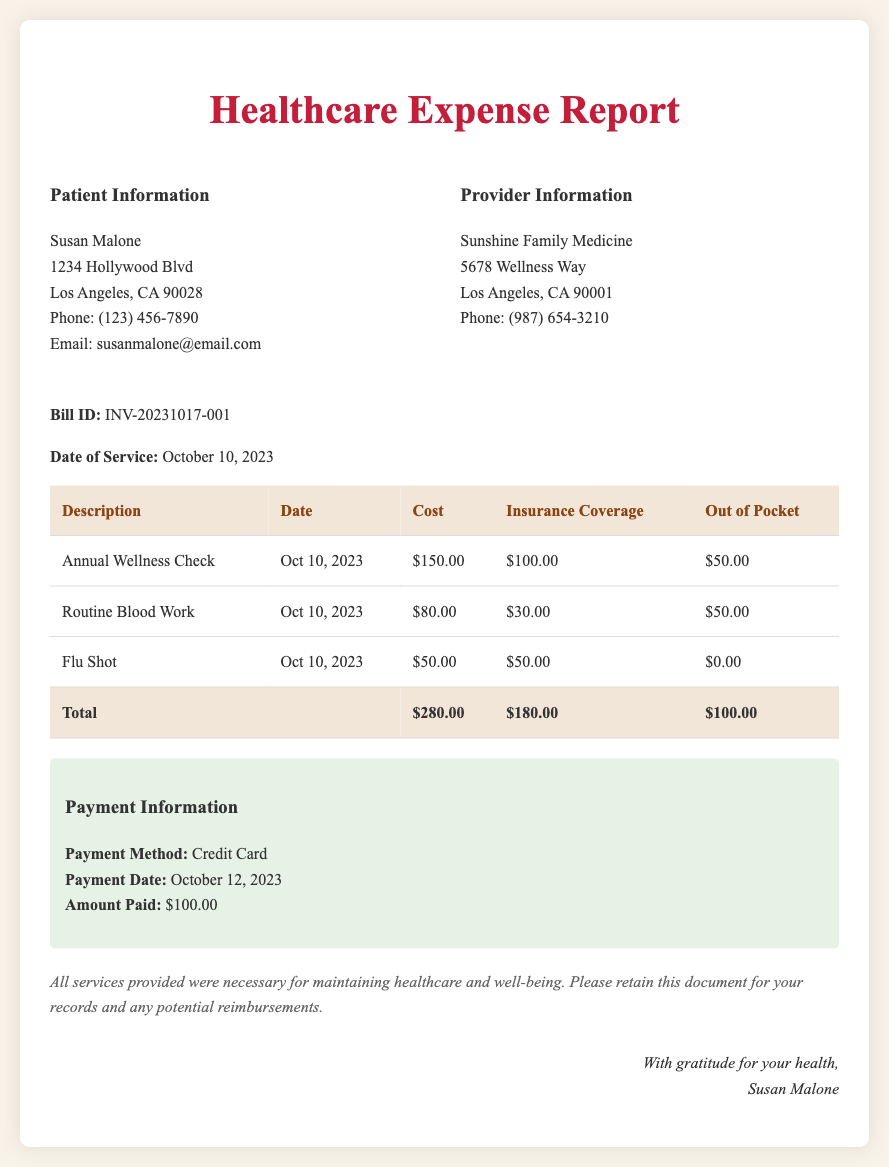what is the patient's name? The patient's name is listed in the document as Susan Malone.
Answer: Susan Malone what is the date of service? The date of service is mentioned as October 10, 2023.
Answer: October 10, 2023 how much was paid for the Annual Wellness Check? The cost for the Annual Wellness Check is specified as $150.00.
Answer: $150.00 how much was the total out-of-pocket cost? The total out-of-pocket cost is the sum of individual out-of-pocket costs listed, which is $50.00 + $50.00 + $0.00 = $100.00.
Answer: $100.00 when was the payment made? The payment date is included in the document as October 12, 2023.
Answer: October 12, 2023 what is the name of the healthcare provider? The healthcare provider is indicated as Sunshine Family Medicine.
Answer: Sunshine Family Medicine how much was the insurance coverage for Routine Blood Work? The insurance coverage for Routine Blood Work is stated as $30.00.
Answer: $30.00 what method of payment was used? The method of payment is detailed as Credit Card.
Answer: Credit Card what services were provided on the date of service? The services provided include Annual Wellness Check, Routine Blood Work, and Flu Shot.
Answer: Annual Wellness Check, Routine Blood Work, Flu Shot 